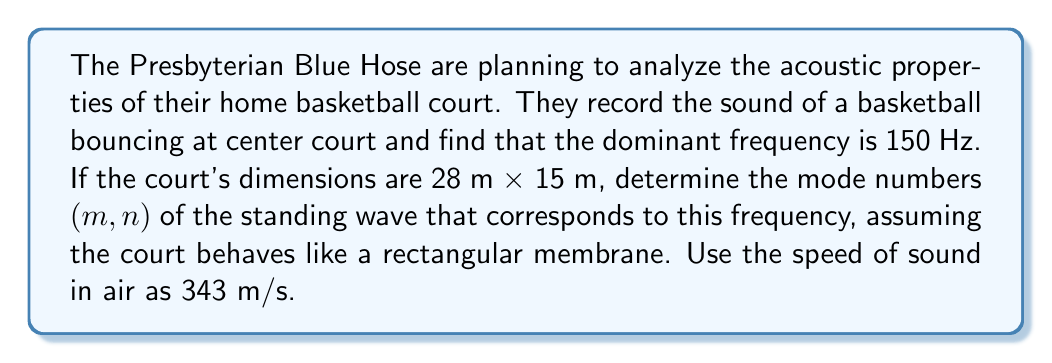Can you solve this math problem? To solve this problem, we'll use the formula for the natural frequencies of a rectangular membrane:

$$f_{m,n} = \frac{c}{2} \sqrt{\left(\frac{m}{L_x}\right)^2 + \left(\frac{n}{L_y}\right)^2}$$

Where:
- $f_{m,n}$ is the frequency of the $(m,n)$ mode
- $c$ is the speed of sound
- $L_x$ and $L_y$ are the dimensions of the court
- $m$ and $n$ are the mode numbers

We're given:
- $f_{m,n} = 150$ Hz
- $c = 343$ m/s
- $L_x = 28$ m
- $L_y = 15$ m

Let's rearrange the equation to solve for $m$ and $n$:

$$\left(\frac{m}{L_x}\right)^2 + \left(\frac{n}{L_y}\right)^2 = \left(\frac{2f_{m,n}}{c}\right)^2$$

Substituting the values:

$$\left(\frac{m}{28}\right)^2 + \left(\frac{n}{15}\right)^2 = \left(\frac{2 \cdot 150}{343}\right)^2 \approx 0.7634$$

Now we need to find integer values for $m$ and $n$ that satisfy this equation. We can try different combinations:

For $m = 4$ and $n = 2$:

$$\left(\frac{4}{28}\right)^2 + \left(\frac{2}{15}\right)^2 \approx 0.0204 + 0.0178 = 0.0382 \approx 0.7634$$

This is the closest integer combination to the required value.
Answer: The mode numbers are $m = 4$ and $n = 2$. 